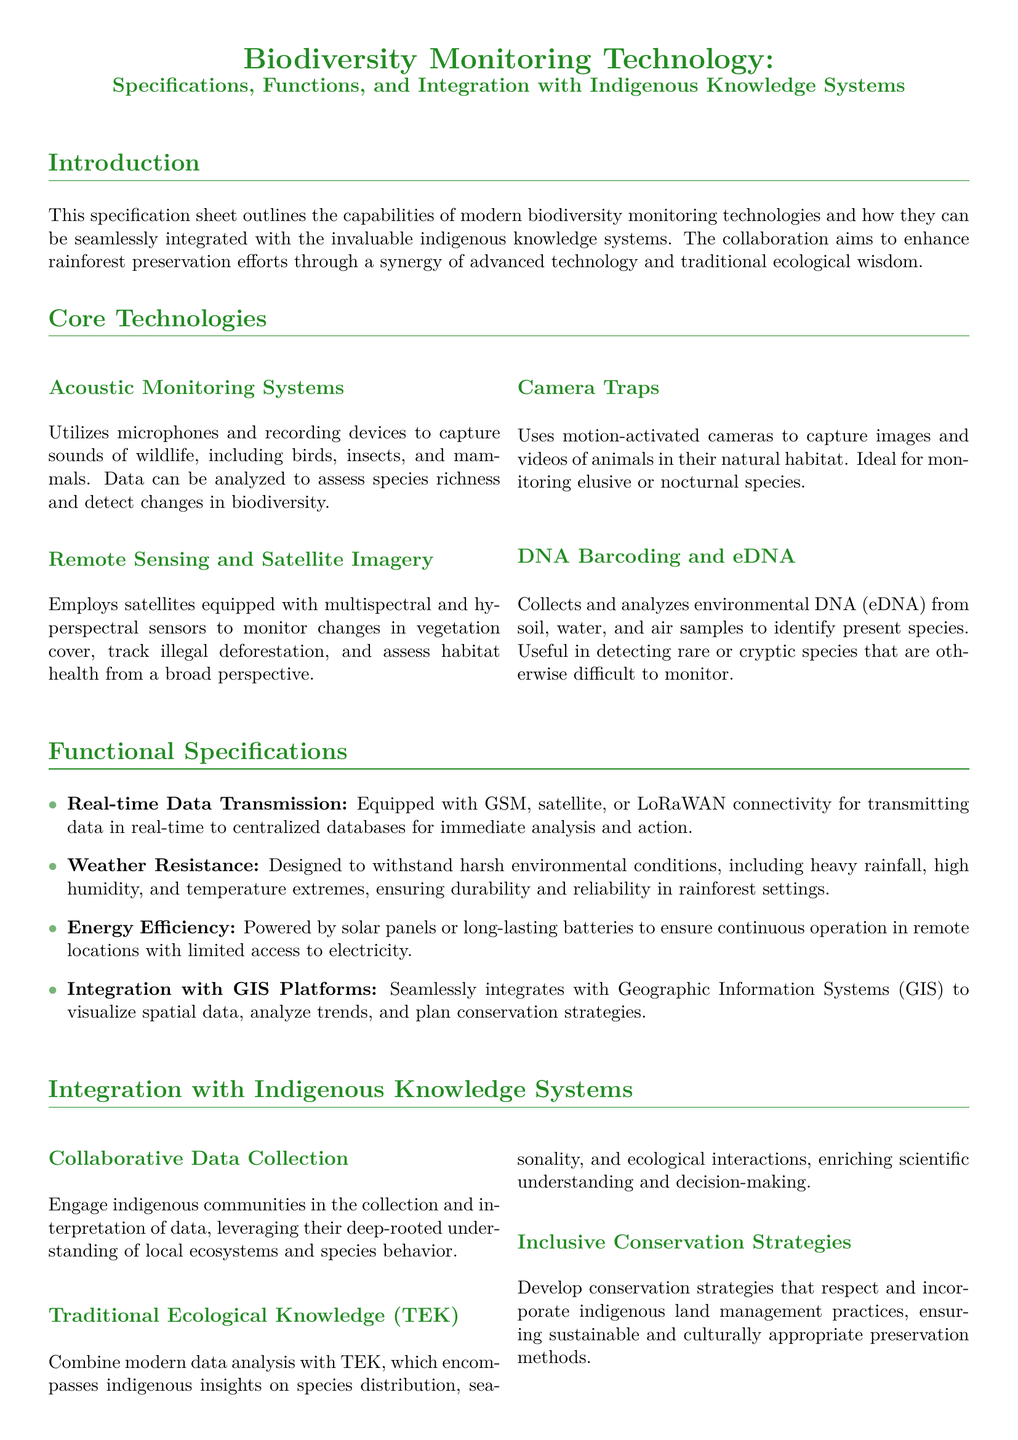What is the primary focus of this specification sheet? The specification sheet outlines the capabilities of modern biodiversity monitoring technologies and their integration with indigenous knowledge systems.
Answer: Biodiversity monitoring technology How many core technologies are listed? The document lists four core technologies used for biodiversity monitoring.
Answer: Four What type of data does acoustic monitoring systems capture? Acoustic monitoring systems utilize microphones and recording devices to capture sounds of wildlife.
Answer: Sounds of wildlife What does TEK stand for in the context of this document? TEK is an acronym mentioned in relation to indigenous insights on ecological interactions and species distribution.
Answer: Traditional Ecological Knowledge Which technology is ideal for monitoring elusive or nocturnal species? The document specifies that camera traps are suitable for monitoring nocturnal and elusive species.
Answer: Camera traps What power source is mentioned to ensure continuous operation in remote locations? The specification sheet mentions solar panels and long-lasting batteries as power sources.
Answer: Solar panels or long-lasting batteries What is a key feature of the integration with indigenous knowledge systems? The document emphasizes collaborative data collection as a significant integration aspect with indigenous knowledge.
Answer: Collaborative data collection What is one function of the remote sensing technology? The remote sensing technology is used for monitoring changes in vegetation cover.
Answer: Monitoring changes in vegetation cover How does the document describe the durability of monitoring technologies? It states that the technologies are designed to withstand harsh environmental conditions.
Answer: Weather resistance 